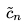Convert formula to latex. <formula><loc_0><loc_0><loc_500><loc_500>\tilde { c } _ { n }</formula> 